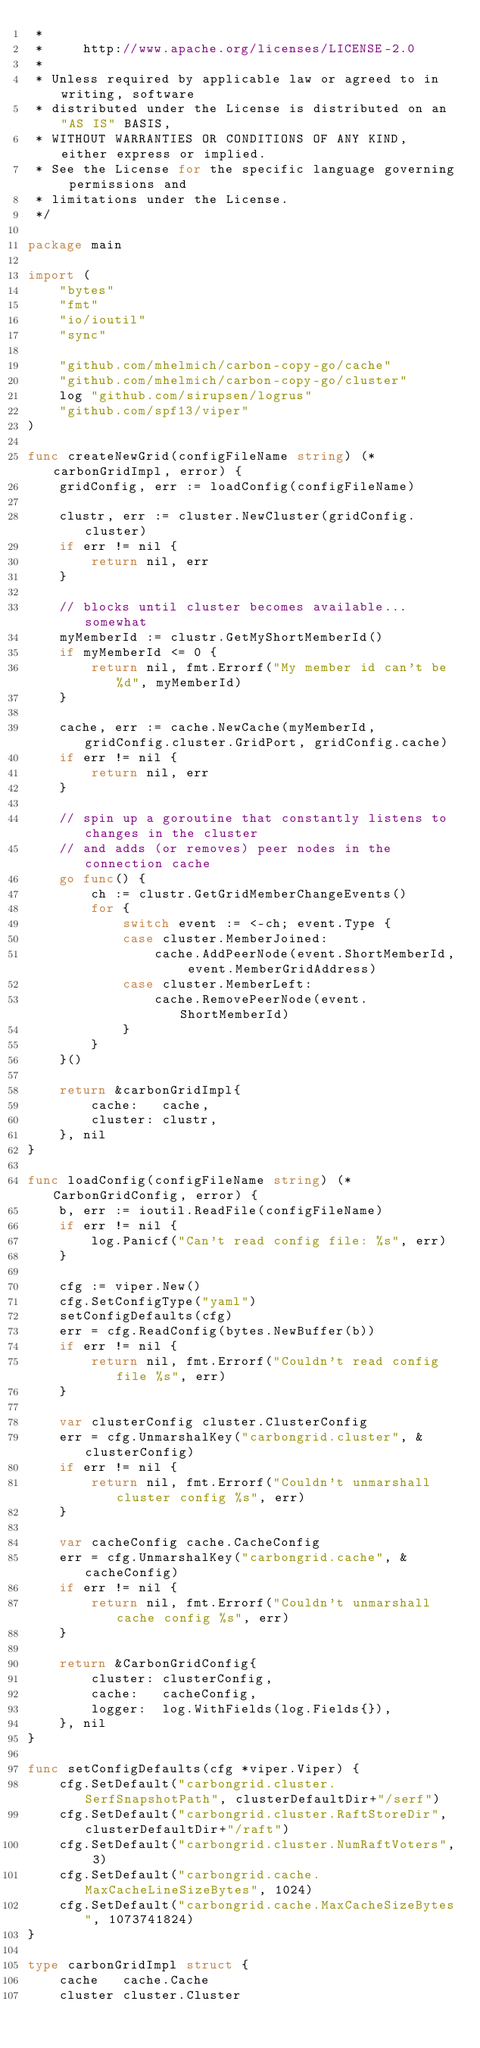Convert code to text. <code><loc_0><loc_0><loc_500><loc_500><_Go_> *
 *     http://www.apache.org/licenses/LICENSE-2.0
 *
 * Unless required by applicable law or agreed to in writing, software
 * distributed under the License is distributed on an "AS IS" BASIS,
 * WITHOUT WARRANTIES OR CONDITIONS OF ANY KIND, either express or implied.
 * See the License for the specific language governing permissions and
 * limitations under the License.
 */

package main

import (
	"bytes"
	"fmt"
	"io/ioutil"
	"sync"

	"github.com/mhelmich/carbon-copy-go/cache"
	"github.com/mhelmich/carbon-copy-go/cluster"
	log "github.com/sirupsen/logrus"
	"github.com/spf13/viper"
)

func createNewGrid(configFileName string) (*carbonGridImpl, error) {
	gridConfig, err := loadConfig(configFileName)

	clustr, err := cluster.NewCluster(gridConfig.cluster)
	if err != nil {
		return nil, err
	}

	// blocks until cluster becomes available...somewhat
	myMemberId := clustr.GetMyShortMemberId()
	if myMemberId <= 0 {
		return nil, fmt.Errorf("My member id can't be %d", myMemberId)
	}

	cache, err := cache.NewCache(myMemberId, gridConfig.cluster.GridPort, gridConfig.cache)
	if err != nil {
		return nil, err
	}

	// spin up a goroutine that constantly listens to changes in the cluster
	// and adds (or removes) peer nodes in the connection cache
	go func() {
		ch := clustr.GetGridMemberChangeEvents()
		for {
			switch event := <-ch; event.Type {
			case cluster.MemberJoined:
				cache.AddPeerNode(event.ShortMemberId, event.MemberGridAddress)
			case cluster.MemberLeft:
				cache.RemovePeerNode(event.ShortMemberId)
			}
		}
	}()

	return &carbonGridImpl{
		cache:   cache,
		cluster: clustr,
	}, nil
}

func loadConfig(configFileName string) (*CarbonGridConfig, error) {
	b, err := ioutil.ReadFile(configFileName)
	if err != nil {
		log.Panicf("Can't read config file: %s", err)
	}

	cfg := viper.New()
	cfg.SetConfigType("yaml")
	setConfigDefaults(cfg)
	err = cfg.ReadConfig(bytes.NewBuffer(b))
	if err != nil {
		return nil, fmt.Errorf("Couldn't read config file %s", err)
	}

	var clusterConfig cluster.ClusterConfig
	err = cfg.UnmarshalKey("carbongrid.cluster", &clusterConfig)
	if err != nil {
		return nil, fmt.Errorf("Couldn't unmarshall cluster config %s", err)
	}

	var cacheConfig cache.CacheConfig
	err = cfg.UnmarshalKey("carbongrid.cache", &cacheConfig)
	if err != nil {
		return nil, fmt.Errorf("Couldn't unmarshall cache config %s", err)
	}

	return &CarbonGridConfig{
		cluster: clusterConfig,
		cache:   cacheConfig,
		logger:  log.WithFields(log.Fields{}),
	}, nil
}

func setConfigDefaults(cfg *viper.Viper) {
	cfg.SetDefault("carbongrid.cluster.SerfSnapshotPath", clusterDefaultDir+"/serf")
	cfg.SetDefault("carbongrid.cluster.RaftStoreDir", clusterDefaultDir+"/raft")
	cfg.SetDefault("carbongrid.cluster.NumRaftVoters", 3)
	cfg.SetDefault("carbongrid.cache.MaxCacheLineSizeBytes", 1024)
	cfg.SetDefault("carbongrid.cache.MaxCacheSizeBytes", 1073741824)
}

type carbonGridImpl struct {
	cache   cache.Cache
	cluster cluster.Cluster</code> 